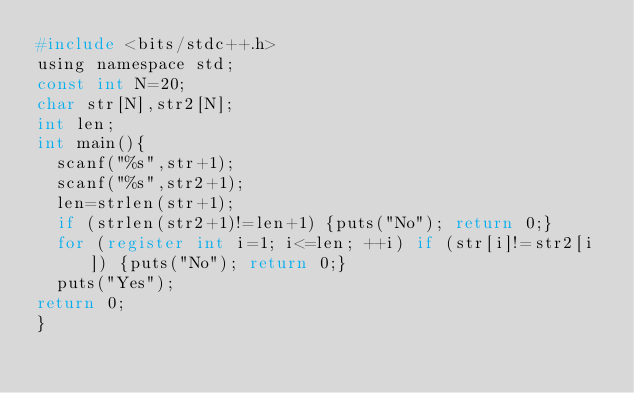<code> <loc_0><loc_0><loc_500><loc_500><_C_>#include <bits/stdc++.h>
using namespace std;
const int N=20;
char str[N],str2[N];
int len;
int main(){
	scanf("%s",str+1);
	scanf("%s",str2+1);
	len=strlen(str+1);
	if (strlen(str2+1)!=len+1) {puts("No"); return 0;}
	for (register int i=1; i<=len; ++i) if (str[i]!=str2[i]) {puts("No"); return 0;}
	puts("Yes");
return 0;
}</code> 